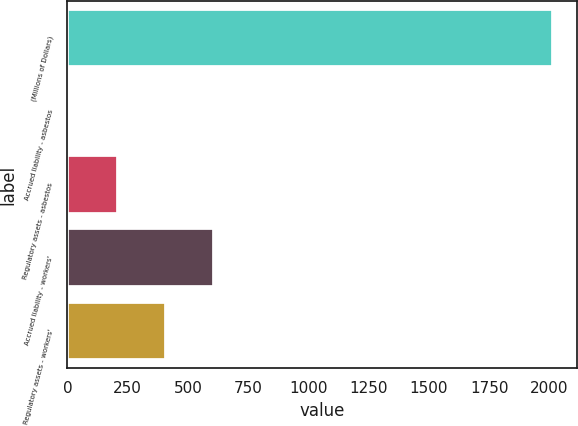<chart> <loc_0><loc_0><loc_500><loc_500><bar_chart><fcel>(Millions of Dollars)<fcel>Accrued liability - asbestos<fcel>Regulatory assets - asbestos<fcel>Accrued liability - workers'<fcel>Regulatory assets - workers'<nl><fcel>2015<fcel>7<fcel>207.8<fcel>609.4<fcel>408.6<nl></chart> 